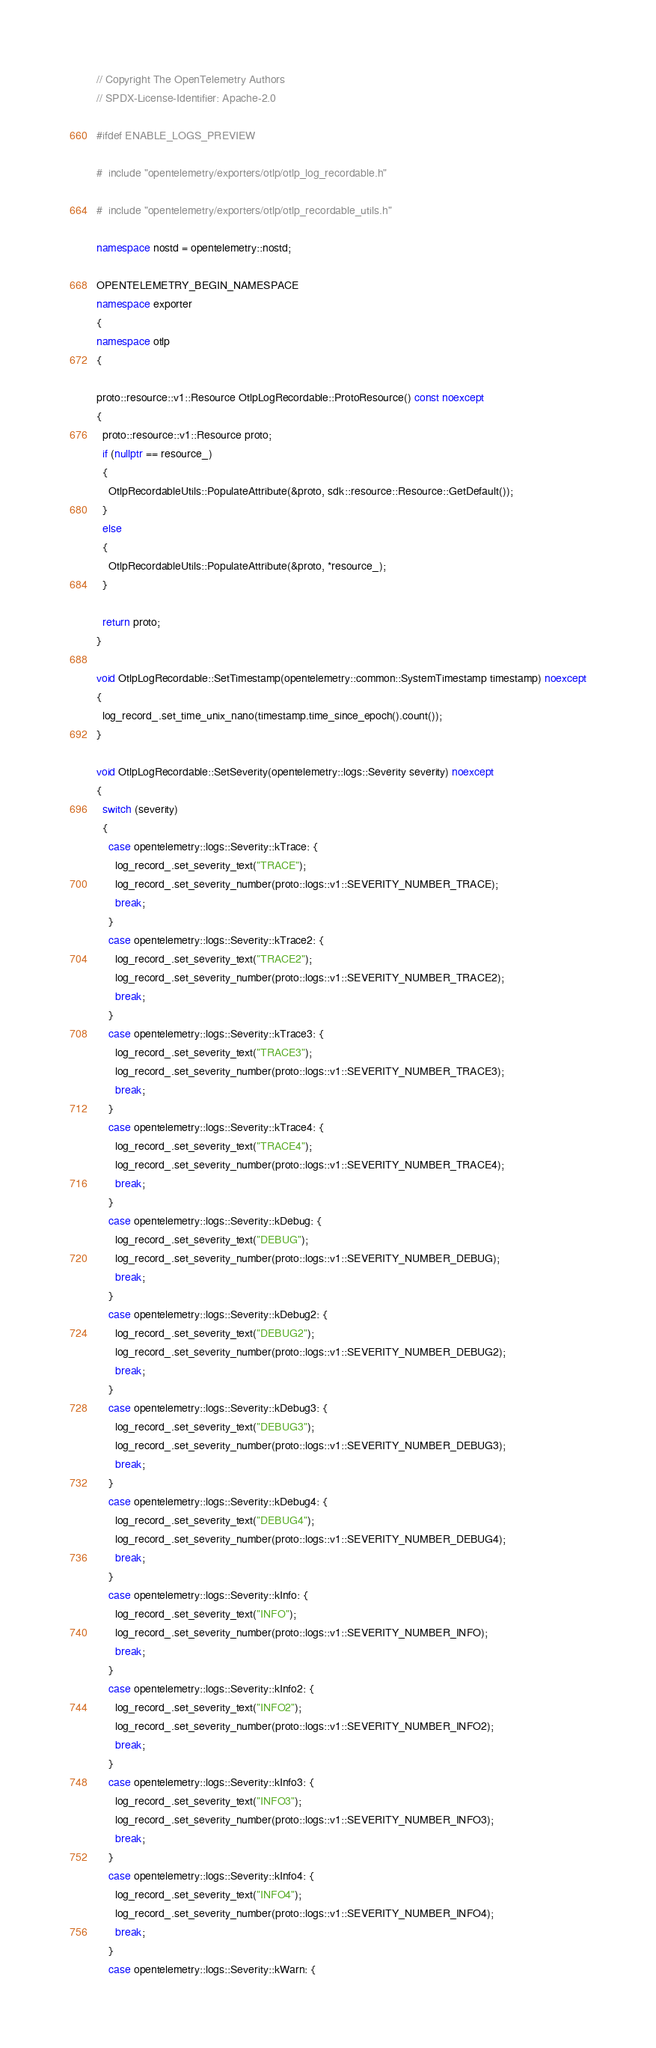Convert code to text. <code><loc_0><loc_0><loc_500><loc_500><_C++_>// Copyright The OpenTelemetry Authors
// SPDX-License-Identifier: Apache-2.0

#ifdef ENABLE_LOGS_PREVIEW

#  include "opentelemetry/exporters/otlp/otlp_log_recordable.h"

#  include "opentelemetry/exporters/otlp/otlp_recordable_utils.h"

namespace nostd = opentelemetry::nostd;

OPENTELEMETRY_BEGIN_NAMESPACE
namespace exporter
{
namespace otlp
{

proto::resource::v1::Resource OtlpLogRecordable::ProtoResource() const noexcept
{
  proto::resource::v1::Resource proto;
  if (nullptr == resource_)
  {
    OtlpRecordableUtils::PopulateAttribute(&proto, sdk::resource::Resource::GetDefault());
  }
  else
  {
    OtlpRecordableUtils::PopulateAttribute(&proto, *resource_);
  }

  return proto;
}

void OtlpLogRecordable::SetTimestamp(opentelemetry::common::SystemTimestamp timestamp) noexcept
{
  log_record_.set_time_unix_nano(timestamp.time_since_epoch().count());
}

void OtlpLogRecordable::SetSeverity(opentelemetry::logs::Severity severity) noexcept
{
  switch (severity)
  {
    case opentelemetry::logs::Severity::kTrace: {
      log_record_.set_severity_text("TRACE");
      log_record_.set_severity_number(proto::logs::v1::SEVERITY_NUMBER_TRACE);
      break;
    }
    case opentelemetry::logs::Severity::kTrace2: {
      log_record_.set_severity_text("TRACE2");
      log_record_.set_severity_number(proto::logs::v1::SEVERITY_NUMBER_TRACE2);
      break;
    }
    case opentelemetry::logs::Severity::kTrace3: {
      log_record_.set_severity_text("TRACE3");
      log_record_.set_severity_number(proto::logs::v1::SEVERITY_NUMBER_TRACE3);
      break;
    }
    case opentelemetry::logs::Severity::kTrace4: {
      log_record_.set_severity_text("TRACE4");
      log_record_.set_severity_number(proto::logs::v1::SEVERITY_NUMBER_TRACE4);
      break;
    }
    case opentelemetry::logs::Severity::kDebug: {
      log_record_.set_severity_text("DEBUG");
      log_record_.set_severity_number(proto::logs::v1::SEVERITY_NUMBER_DEBUG);
      break;
    }
    case opentelemetry::logs::Severity::kDebug2: {
      log_record_.set_severity_text("DEBUG2");
      log_record_.set_severity_number(proto::logs::v1::SEVERITY_NUMBER_DEBUG2);
      break;
    }
    case opentelemetry::logs::Severity::kDebug3: {
      log_record_.set_severity_text("DEBUG3");
      log_record_.set_severity_number(proto::logs::v1::SEVERITY_NUMBER_DEBUG3);
      break;
    }
    case opentelemetry::logs::Severity::kDebug4: {
      log_record_.set_severity_text("DEBUG4");
      log_record_.set_severity_number(proto::logs::v1::SEVERITY_NUMBER_DEBUG4);
      break;
    }
    case opentelemetry::logs::Severity::kInfo: {
      log_record_.set_severity_text("INFO");
      log_record_.set_severity_number(proto::logs::v1::SEVERITY_NUMBER_INFO);
      break;
    }
    case opentelemetry::logs::Severity::kInfo2: {
      log_record_.set_severity_text("INFO2");
      log_record_.set_severity_number(proto::logs::v1::SEVERITY_NUMBER_INFO2);
      break;
    }
    case opentelemetry::logs::Severity::kInfo3: {
      log_record_.set_severity_text("INFO3");
      log_record_.set_severity_number(proto::logs::v1::SEVERITY_NUMBER_INFO3);
      break;
    }
    case opentelemetry::logs::Severity::kInfo4: {
      log_record_.set_severity_text("INFO4");
      log_record_.set_severity_number(proto::logs::v1::SEVERITY_NUMBER_INFO4);
      break;
    }
    case opentelemetry::logs::Severity::kWarn: {</code> 